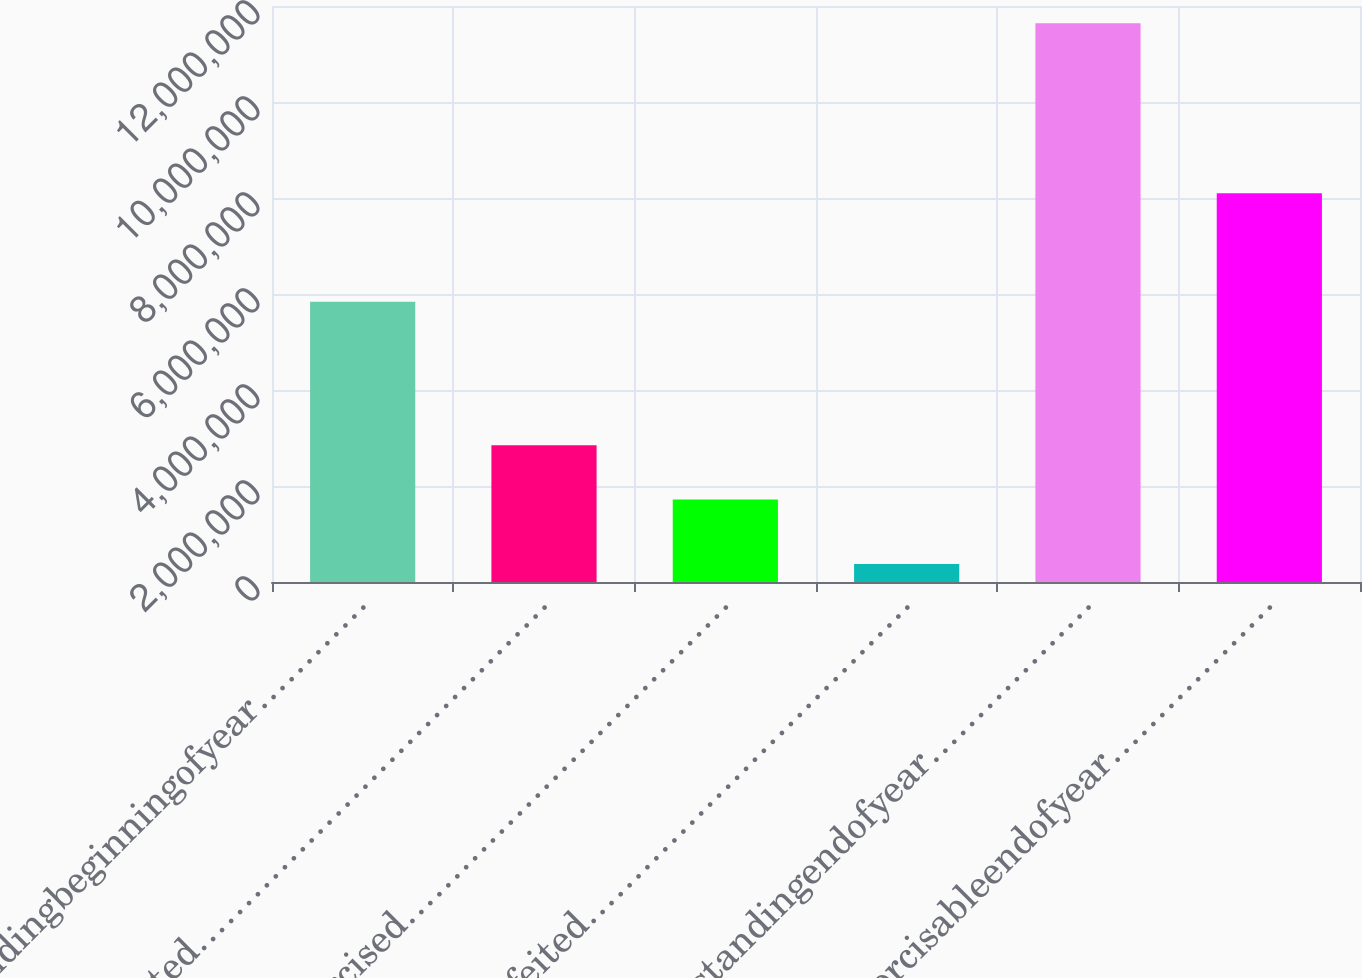<chart> <loc_0><loc_0><loc_500><loc_500><bar_chart><fcel>Outstandingbeginningofyear…………<fcel>Granted…………………………………<fcel>Exercised………………………………<fcel>Forfeited………………………………<fcel>Outstandingendofyear………………<fcel>Exercisableendofyear………………<nl><fcel>5.83942e+06<fcel>2.84697e+06<fcel>1.72051e+06<fcel>376911<fcel>1.16416e+07<fcel>8.10057e+06<nl></chart> 